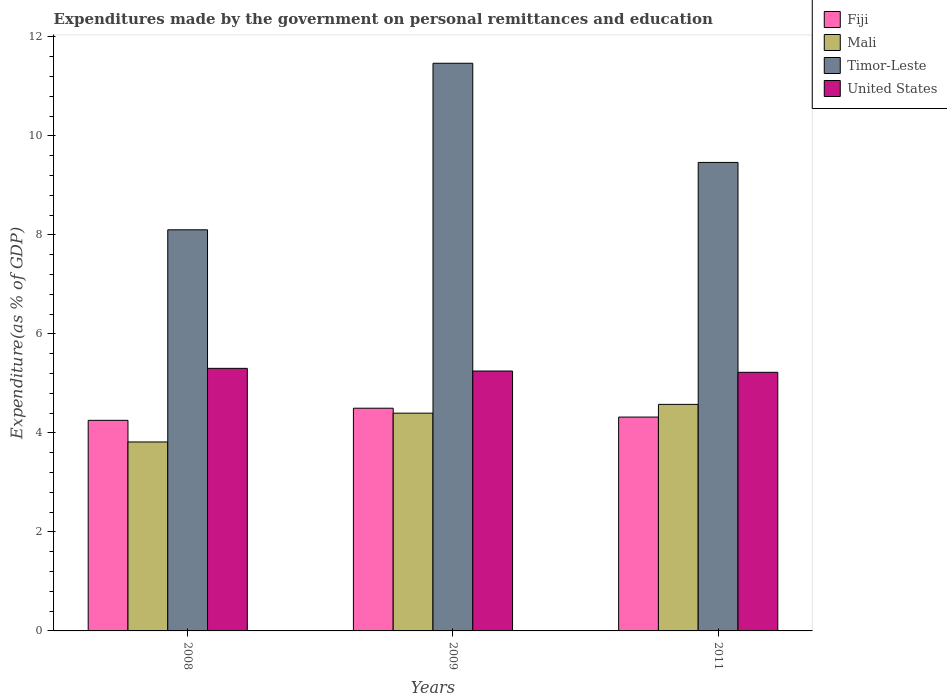How many different coloured bars are there?
Your answer should be very brief. 4. Are the number of bars on each tick of the X-axis equal?
Give a very brief answer. Yes. How many bars are there on the 3rd tick from the right?
Offer a terse response. 4. What is the label of the 2nd group of bars from the left?
Make the answer very short. 2009. What is the expenditures made by the government on personal remittances and education in Fiji in 2008?
Keep it short and to the point. 4.25. Across all years, what is the maximum expenditures made by the government on personal remittances and education in United States?
Keep it short and to the point. 5.3. Across all years, what is the minimum expenditures made by the government on personal remittances and education in Timor-Leste?
Offer a very short reply. 8.1. In which year was the expenditures made by the government on personal remittances and education in United States maximum?
Provide a short and direct response. 2008. In which year was the expenditures made by the government on personal remittances and education in Timor-Leste minimum?
Provide a succinct answer. 2008. What is the total expenditures made by the government on personal remittances and education in United States in the graph?
Offer a terse response. 15.78. What is the difference between the expenditures made by the government on personal remittances and education in Mali in 2008 and that in 2009?
Give a very brief answer. -0.58. What is the difference between the expenditures made by the government on personal remittances and education in United States in 2011 and the expenditures made by the government on personal remittances and education in Fiji in 2009?
Give a very brief answer. 0.73. What is the average expenditures made by the government on personal remittances and education in Fiji per year?
Make the answer very short. 4.36. In the year 2009, what is the difference between the expenditures made by the government on personal remittances and education in Mali and expenditures made by the government on personal remittances and education in United States?
Offer a terse response. -0.85. What is the ratio of the expenditures made by the government on personal remittances and education in Timor-Leste in 2008 to that in 2009?
Keep it short and to the point. 0.71. What is the difference between the highest and the second highest expenditures made by the government on personal remittances and education in Fiji?
Offer a terse response. 0.18. What is the difference between the highest and the lowest expenditures made by the government on personal remittances and education in Mali?
Keep it short and to the point. 0.76. What does the 1st bar from the left in 2009 represents?
Make the answer very short. Fiji. What does the 3rd bar from the right in 2008 represents?
Provide a short and direct response. Mali. Is it the case that in every year, the sum of the expenditures made by the government on personal remittances and education in Mali and expenditures made by the government on personal remittances and education in Fiji is greater than the expenditures made by the government on personal remittances and education in United States?
Provide a short and direct response. Yes. Are all the bars in the graph horizontal?
Provide a succinct answer. No. How many legend labels are there?
Provide a succinct answer. 4. How are the legend labels stacked?
Offer a terse response. Vertical. What is the title of the graph?
Provide a succinct answer. Expenditures made by the government on personal remittances and education. Does "Guinea-Bissau" appear as one of the legend labels in the graph?
Your response must be concise. No. What is the label or title of the X-axis?
Keep it short and to the point. Years. What is the label or title of the Y-axis?
Offer a terse response. Expenditure(as % of GDP). What is the Expenditure(as % of GDP) of Fiji in 2008?
Make the answer very short. 4.25. What is the Expenditure(as % of GDP) of Mali in 2008?
Provide a succinct answer. 3.82. What is the Expenditure(as % of GDP) of Timor-Leste in 2008?
Make the answer very short. 8.1. What is the Expenditure(as % of GDP) of United States in 2008?
Provide a succinct answer. 5.3. What is the Expenditure(as % of GDP) in Fiji in 2009?
Keep it short and to the point. 4.5. What is the Expenditure(as % of GDP) of Mali in 2009?
Offer a very short reply. 4.4. What is the Expenditure(as % of GDP) in Timor-Leste in 2009?
Make the answer very short. 11.47. What is the Expenditure(as % of GDP) of United States in 2009?
Provide a short and direct response. 5.25. What is the Expenditure(as % of GDP) in Fiji in 2011?
Ensure brevity in your answer.  4.32. What is the Expenditure(as % of GDP) in Mali in 2011?
Ensure brevity in your answer.  4.58. What is the Expenditure(as % of GDP) in Timor-Leste in 2011?
Your answer should be compact. 9.46. What is the Expenditure(as % of GDP) of United States in 2011?
Your answer should be compact. 5.22. Across all years, what is the maximum Expenditure(as % of GDP) of Fiji?
Your response must be concise. 4.5. Across all years, what is the maximum Expenditure(as % of GDP) of Mali?
Offer a terse response. 4.58. Across all years, what is the maximum Expenditure(as % of GDP) of Timor-Leste?
Keep it short and to the point. 11.47. Across all years, what is the maximum Expenditure(as % of GDP) in United States?
Make the answer very short. 5.3. Across all years, what is the minimum Expenditure(as % of GDP) in Fiji?
Give a very brief answer. 4.25. Across all years, what is the minimum Expenditure(as % of GDP) in Mali?
Give a very brief answer. 3.82. Across all years, what is the minimum Expenditure(as % of GDP) of Timor-Leste?
Provide a succinct answer. 8.1. Across all years, what is the minimum Expenditure(as % of GDP) in United States?
Your answer should be compact. 5.22. What is the total Expenditure(as % of GDP) of Fiji in the graph?
Offer a terse response. 13.07. What is the total Expenditure(as % of GDP) in Mali in the graph?
Your answer should be compact. 12.79. What is the total Expenditure(as % of GDP) of Timor-Leste in the graph?
Offer a terse response. 29.03. What is the total Expenditure(as % of GDP) of United States in the graph?
Give a very brief answer. 15.78. What is the difference between the Expenditure(as % of GDP) of Fiji in 2008 and that in 2009?
Offer a terse response. -0.24. What is the difference between the Expenditure(as % of GDP) of Mali in 2008 and that in 2009?
Offer a terse response. -0.58. What is the difference between the Expenditure(as % of GDP) in Timor-Leste in 2008 and that in 2009?
Offer a terse response. -3.36. What is the difference between the Expenditure(as % of GDP) in United States in 2008 and that in 2009?
Provide a succinct answer. 0.05. What is the difference between the Expenditure(as % of GDP) of Fiji in 2008 and that in 2011?
Provide a short and direct response. -0.07. What is the difference between the Expenditure(as % of GDP) of Mali in 2008 and that in 2011?
Your answer should be compact. -0.76. What is the difference between the Expenditure(as % of GDP) of Timor-Leste in 2008 and that in 2011?
Your answer should be compact. -1.36. What is the difference between the Expenditure(as % of GDP) in United States in 2008 and that in 2011?
Your answer should be compact. 0.08. What is the difference between the Expenditure(as % of GDP) in Fiji in 2009 and that in 2011?
Keep it short and to the point. 0.18. What is the difference between the Expenditure(as % of GDP) in Mali in 2009 and that in 2011?
Provide a succinct answer. -0.18. What is the difference between the Expenditure(as % of GDP) in Timor-Leste in 2009 and that in 2011?
Provide a short and direct response. 2. What is the difference between the Expenditure(as % of GDP) in United States in 2009 and that in 2011?
Your answer should be compact. 0.03. What is the difference between the Expenditure(as % of GDP) in Fiji in 2008 and the Expenditure(as % of GDP) in Mali in 2009?
Provide a succinct answer. -0.14. What is the difference between the Expenditure(as % of GDP) in Fiji in 2008 and the Expenditure(as % of GDP) in Timor-Leste in 2009?
Your response must be concise. -7.21. What is the difference between the Expenditure(as % of GDP) in Fiji in 2008 and the Expenditure(as % of GDP) in United States in 2009?
Provide a succinct answer. -1. What is the difference between the Expenditure(as % of GDP) of Mali in 2008 and the Expenditure(as % of GDP) of Timor-Leste in 2009?
Your answer should be very brief. -7.65. What is the difference between the Expenditure(as % of GDP) in Mali in 2008 and the Expenditure(as % of GDP) in United States in 2009?
Ensure brevity in your answer.  -1.43. What is the difference between the Expenditure(as % of GDP) of Timor-Leste in 2008 and the Expenditure(as % of GDP) of United States in 2009?
Provide a short and direct response. 2.85. What is the difference between the Expenditure(as % of GDP) in Fiji in 2008 and the Expenditure(as % of GDP) in Mali in 2011?
Your answer should be very brief. -0.32. What is the difference between the Expenditure(as % of GDP) of Fiji in 2008 and the Expenditure(as % of GDP) of Timor-Leste in 2011?
Provide a short and direct response. -5.21. What is the difference between the Expenditure(as % of GDP) in Fiji in 2008 and the Expenditure(as % of GDP) in United States in 2011?
Make the answer very short. -0.97. What is the difference between the Expenditure(as % of GDP) in Mali in 2008 and the Expenditure(as % of GDP) in Timor-Leste in 2011?
Provide a succinct answer. -5.65. What is the difference between the Expenditure(as % of GDP) in Mali in 2008 and the Expenditure(as % of GDP) in United States in 2011?
Give a very brief answer. -1.41. What is the difference between the Expenditure(as % of GDP) in Timor-Leste in 2008 and the Expenditure(as % of GDP) in United States in 2011?
Keep it short and to the point. 2.88. What is the difference between the Expenditure(as % of GDP) of Fiji in 2009 and the Expenditure(as % of GDP) of Mali in 2011?
Offer a terse response. -0.08. What is the difference between the Expenditure(as % of GDP) in Fiji in 2009 and the Expenditure(as % of GDP) in Timor-Leste in 2011?
Give a very brief answer. -4.96. What is the difference between the Expenditure(as % of GDP) in Fiji in 2009 and the Expenditure(as % of GDP) in United States in 2011?
Your answer should be compact. -0.73. What is the difference between the Expenditure(as % of GDP) of Mali in 2009 and the Expenditure(as % of GDP) of Timor-Leste in 2011?
Your answer should be very brief. -5.06. What is the difference between the Expenditure(as % of GDP) of Mali in 2009 and the Expenditure(as % of GDP) of United States in 2011?
Provide a short and direct response. -0.83. What is the difference between the Expenditure(as % of GDP) in Timor-Leste in 2009 and the Expenditure(as % of GDP) in United States in 2011?
Keep it short and to the point. 6.24. What is the average Expenditure(as % of GDP) of Fiji per year?
Your answer should be very brief. 4.36. What is the average Expenditure(as % of GDP) in Mali per year?
Your answer should be compact. 4.26. What is the average Expenditure(as % of GDP) in Timor-Leste per year?
Your answer should be compact. 9.68. What is the average Expenditure(as % of GDP) in United States per year?
Give a very brief answer. 5.26. In the year 2008, what is the difference between the Expenditure(as % of GDP) in Fiji and Expenditure(as % of GDP) in Mali?
Your answer should be compact. 0.44. In the year 2008, what is the difference between the Expenditure(as % of GDP) of Fiji and Expenditure(as % of GDP) of Timor-Leste?
Offer a very short reply. -3.85. In the year 2008, what is the difference between the Expenditure(as % of GDP) in Fiji and Expenditure(as % of GDP) in United States?
Keep it short and to the point. -1.05. In the year 2008, what is the difference between the Expenditure(as % of GDP) in Mali and Expenditure(as % of GDP) in Timor-Leste?
Keep it short and to the point. -4.29. In the year 2008, what is the difference between the Expenditure(as % of GDP) in Mali and Expenditure(as % of GDP) in United States?
Ensure brevity in your answer.  -1.49. In the year 2008, what is the difference between the Expenditure(as % of GDP) in Timor-Leste and Expenditure(as % of GDP) in United States?
Ensure brevity in your answer.  2.8. In the year 2009, what is the difference between the Expenditure(as % of GDP) of Fiji and Expenditure(as % of GDP) of Mali?
Provide a succinct answer. 0.1. In the year 2009, what is the difference between the Expenditure(as % of GDP) of Fiji and Expenditure(as % of GDP) of Timor-Leste?
Offer a very short reply. -6.97. In the year 2009, what is the difference between the Expenditure(as % of GDP) in Fiji and Expenditure(as % of GDP) in United States?
Offer a very short reply. -0.75. In the year 2009, what is the difference between the Expenditure(as % of GDP) of Mali and Expenditure(as % of GDP) of Timor-Leste?
Give a very brief answer. -7.07. In the year 2009, what is the difference between the Expenditure(as % of GDP) in Mali and Expenditure(as % of GDP) in United States?
Give a very brief answer. -0.85. In the year 2009, what is the difference between the Expenditure(as % of GDP) in Timor-Leste and Expenditure(as % of GDP) in United States?
Provide a short and direct response. 6.22. In the year 2011, what is the difference between the Expenditure(as % of GDP) in Fiji and Expenditure(as % of GDP) in Mali?
Your response must be concise. -0.26. In the year 2011, what is the difference between the Expenditure(as % of GDP) of Fiji and Expenditure(as % of GDP) of Timor-Leste?
Provide a succinct answer. -5.14. In the year 2011, what is the difference between the Expenditure(as % of GDP) in Fiji and Expenditure(as % of GDP) in United States?
Offer a terse response. -0.9. In the year 2011, what is the difference between the Expenditure(as % of GDP) of Mali and Expenditure(as % of GDP) of Timor-Leste?
Give a very brief answer. -4.89. In the year 2011, what is the difference between the Expenditure(as % of GDP) of Mali and Expenditure(as % of GDP) of United States?
Offer a terse response. -0.65. In the year 2011, what is the difference between the Expenditure(as % of GDP) in Timor-Leste and Expenditure(as % of GDP) in United States?
Provide a succinct answer. 4.24. What is the ratio of the Expenditure(as % of GDP) in Fiji in 2008 to that in 2009?
Your response must be concise. 0.95. What is the ratio of the Expenditure(as % of GDP) of Mali in 2008 to that in 2009?
Make the answer very short. 0.87. What is the ratio of the Expenditure(as % of GDP) in Timor-Leste in 2008 to that in 2009?
Offer a terse response. 0.71. What is the ratio of the Expenditure(as % of GDP) in United States in 2008 to that in 2009?
Your answer should be compact. 1.01. What is the ratio of the Expenditure(as % of GDP) of Fiji in 2008 to that in 2011?
Your response must be concise. 0.98. What is the ratio of the Expenditure(as % of GDP) in Mali in 2008 to that in 2011?
Offer a terse response. 0.83. What is the ratio of the Expenditure(as % of GDP) in Timor-Leste in 2008 to that in 2011?
Your answer should be very brief. 0.86. What is the ratio of the Expenditure(as % of GDP) of United States in 2008 to that in 2011?
Ensure brevity in your answer.  1.02. What is the ratio of the Expenditure(as % of GDP) in Fiji in 2009 to that in 2011?
Your answer should be very brief. 1.04. What is the ratio of the Expenditure(as % of GDP) of Mali in 2009 to that in 2011?
Offer a very short reply. 0.96. What is the ratio of the Expenditure(as % of GDP) of Timor-Leste in 2009 to that in 2011?
Provide a short and direct response. 1.21. What is the difference between the highest and the second highest Expenditure(as % of GDP) of Fiji?
Offer a very short reply. 0.18. What is the difference between the highest and the second highest Expenditure(as % of GDP) of Mali?
Offer a terse response. 0.18. What is the difference between the highest and the second highest Expenditure(as % of GDP) of Timor-Leste?
Ensure brevity in your answer.  2. What is the difference between the highest and the second highest Expenditure(as % of GDP) in United States?
Offer a terse response. 0.05. What is the difference between the highest and the lowest Expenditure(as % of GDP) of Fiji?
Give a very brief answer. 0.24. What is the difference between the highest and the lowest Expenditure(as % of GDP) of Mali?
Provide a short and direct response. 0.76. What is the difference between the highest and the lowest Expenditure(as % of GDP) of Timor-Leste?
Offer a terse response. 3.36. What is the difference between the highest and the lowest Expenditure(as % of GDP) of United States?
Provide a succinct answer. 0.08. 